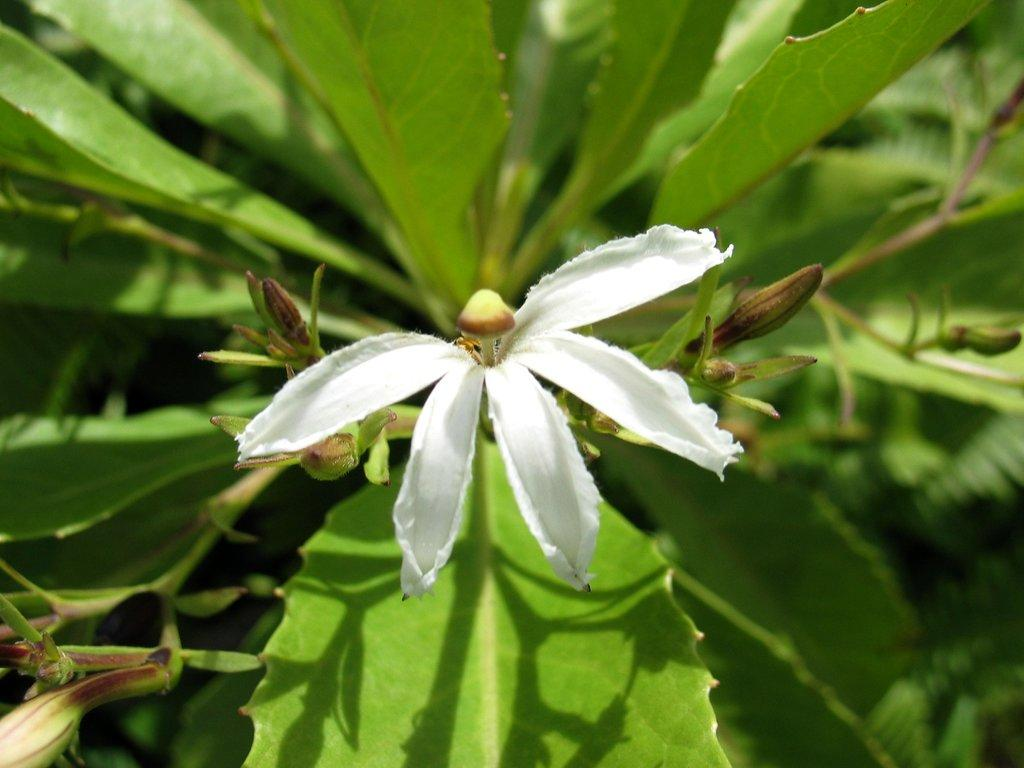What type of plant is visible in the image? The image features a plant with a flower. Where is the flower located on the plant? The flower is in the center of the image. How does the flower help the geese learn to breathe in the image? There are no geese or any indication of learning or breathing in the image; it only features a flower on a plant. 